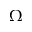Convert formula to latex. <formula><loc_0><loc_0><loc_500><loc_500>\Omega</formula> 